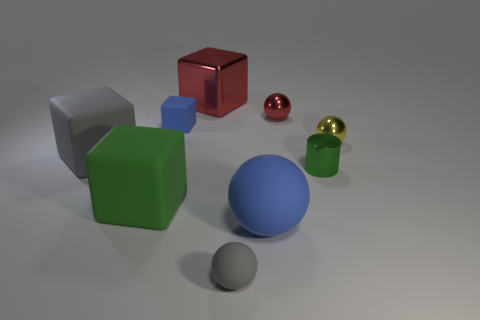Subtract all red cubes. How many cubes are left? 3 Subtract all matte blocks. How many blocks are left? 1 Subtract all cylinders. How many objects are left? 8 Subtract all brown balls. Subtract all yellow cylinders. How many balls are left? 4 Subtract all yellow cylinders. How many red balls are left? 1 Subtract all red objects. Subtract all small red balls. How many objects are left? 6 Add 7 matte blocks. How many matte blocks are left? 10 Add 5 green objects. How many green objects exist? 7 Subtract 1 green cylinders. How many objects are left? 8 Subtract 1 blocks. How many blocks are left? 3 